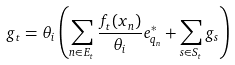<formula> <loc_0><loc_0><loc_500><loc_500>g _ { t } = \theta _ { i } \left ( \sum _ { n \in E _ { t } } \frac { f _ { t } ( x _ { n } ) } { \theta _ { i } } e _ { q _ { n } } ^ { * } + \sum _ { s \in S _ { t } } g _ { s } \right )</formula> 